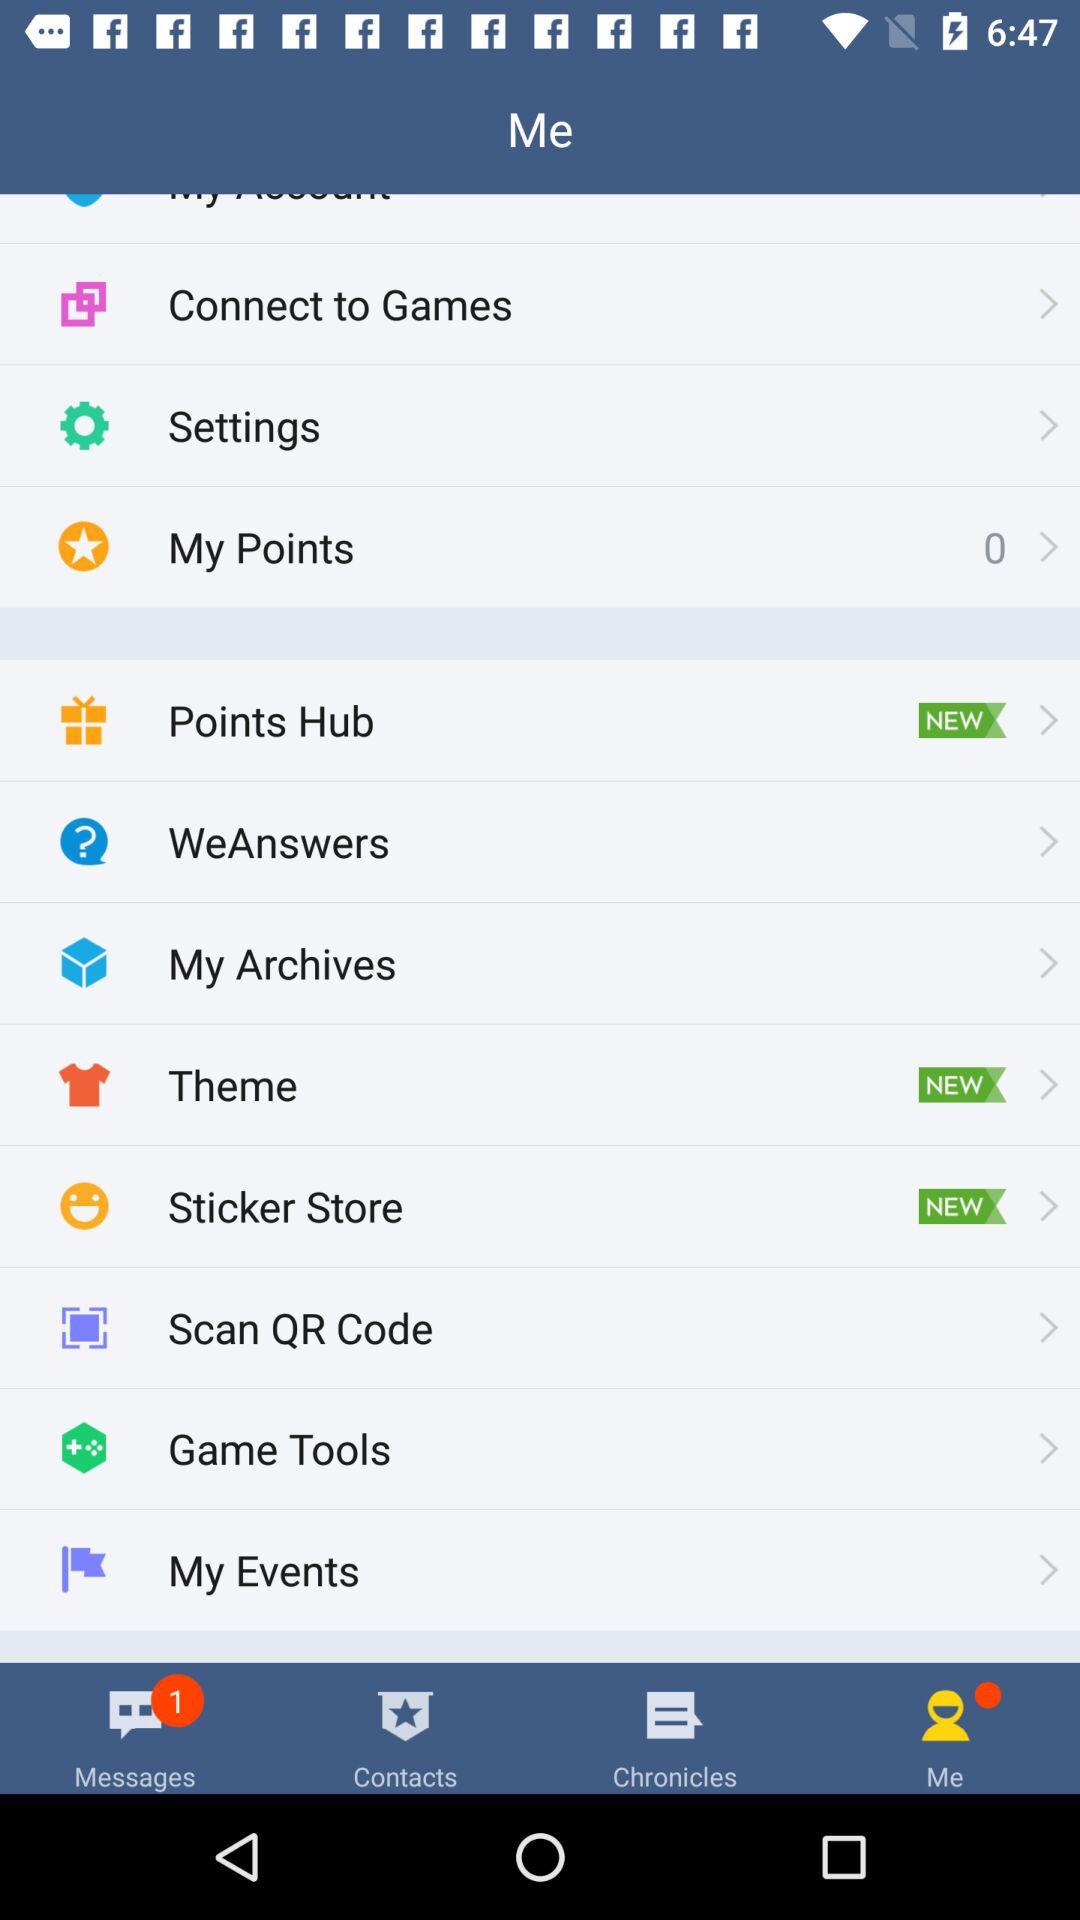Which are the new options in the list? The new options are "Points Hub", "Theme" and "Sticker Store". 